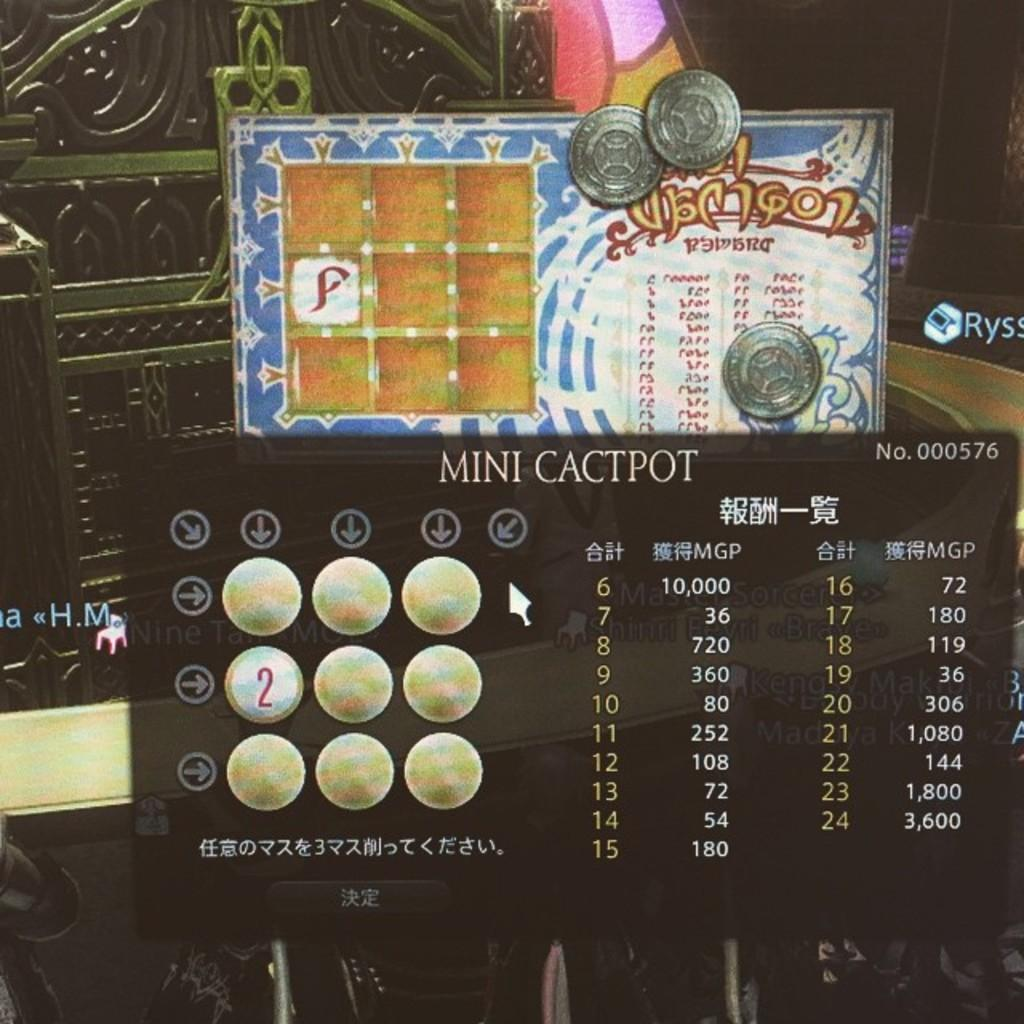<image>
Create a compact narrative representing the image presented. a screen shot of the video game mini cactpot and the scoreboard 